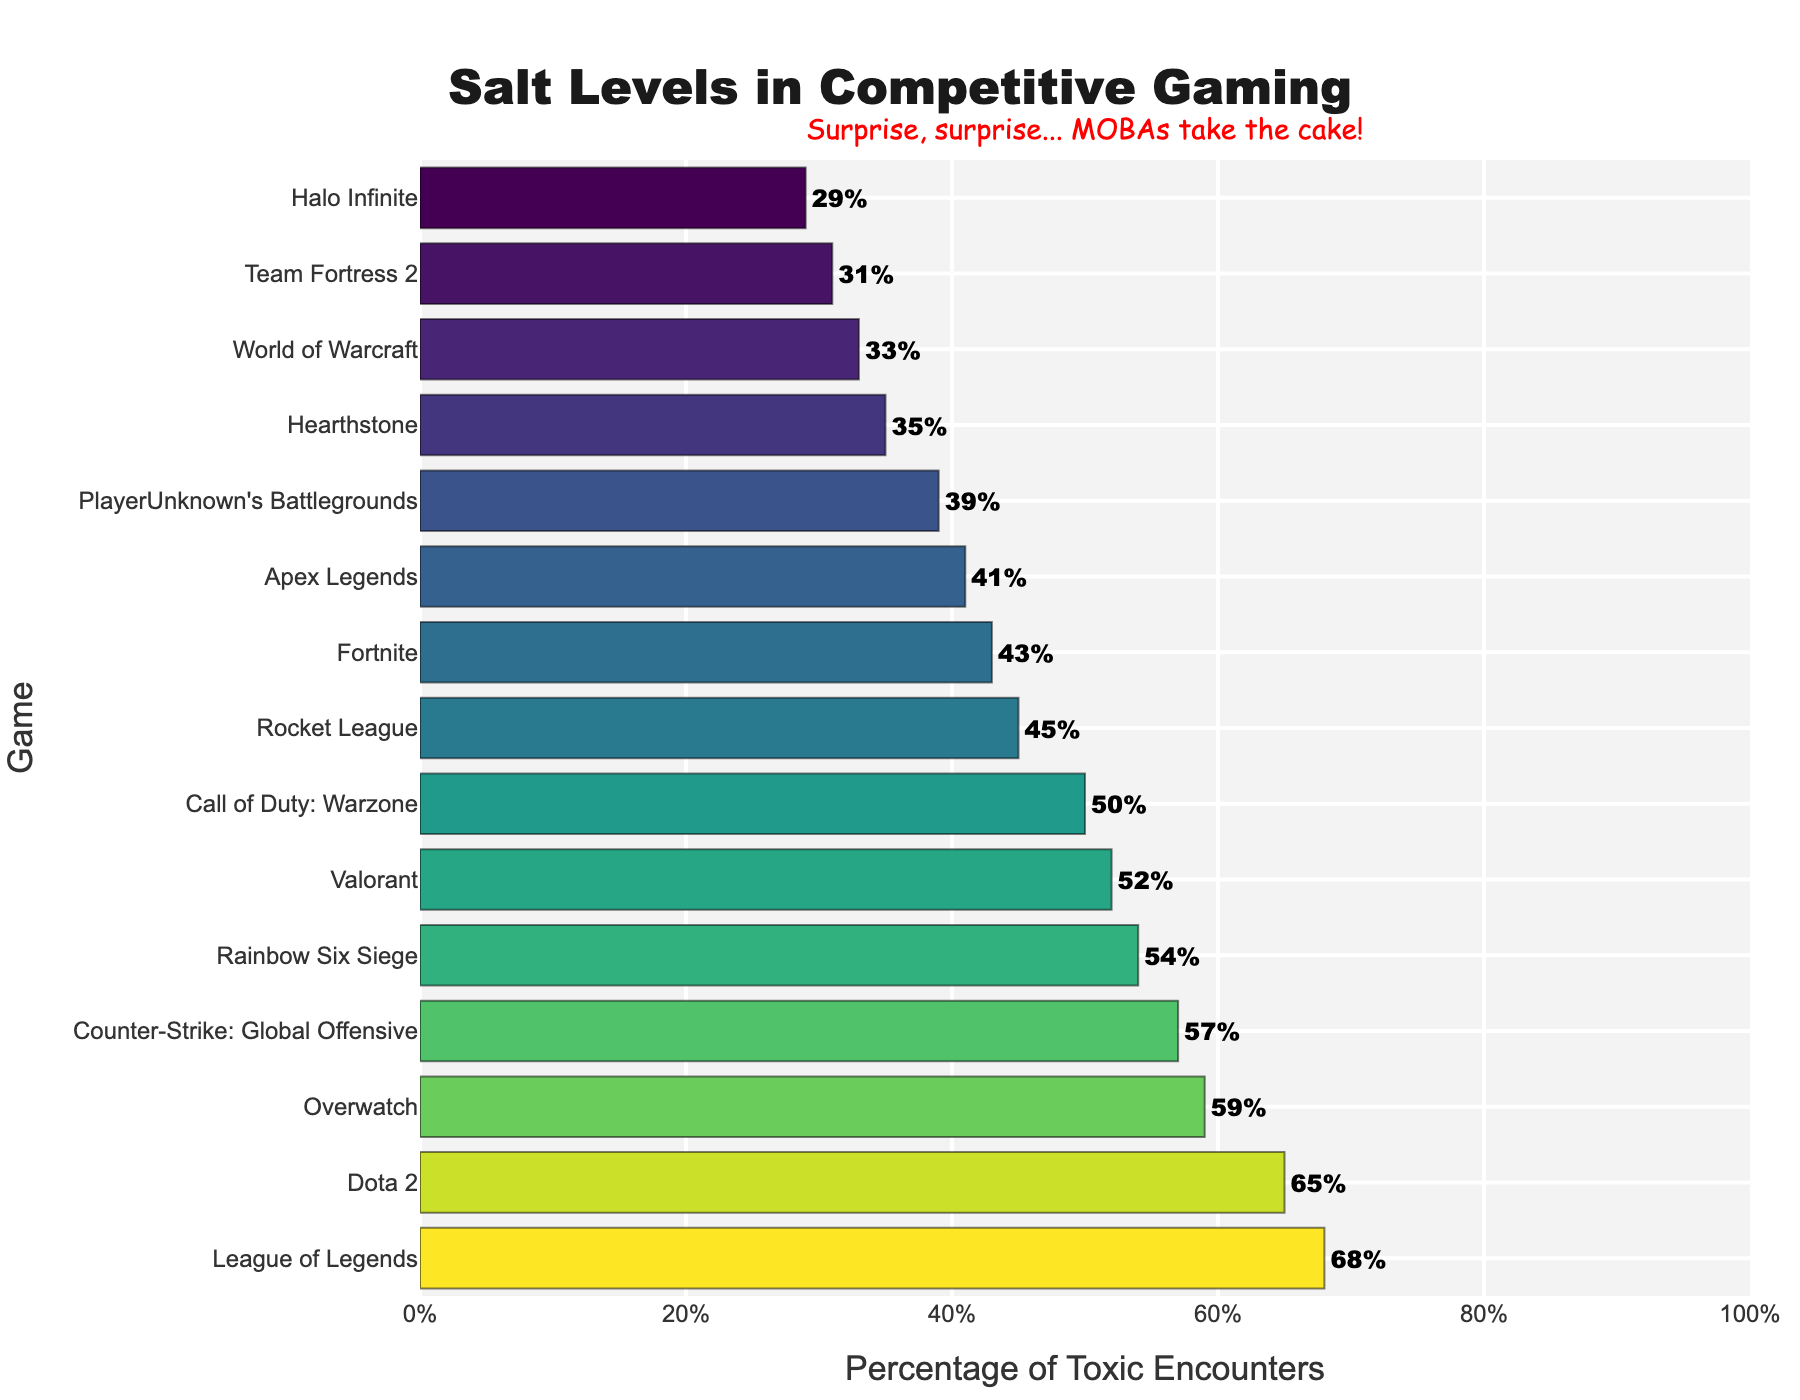what percentage of toxic encounters does League of Legends have? League of Legends has the bar with the highest value in the figure, which is labeled as 68%.
Answer: 68% which game has fewer toxic encounters, Fortnite or Valorant? Compare the lengths of the bars for Fortnite and Valorant. Fortnite is at 43%, and Valorant is at 52%, making Fortnite's value lower.
Answer: Fortnite what's the difference in the percentage of toxic encounters between Overwatch and Call of Duty: Warzone? Overwatch has 59% while Call of Duty: Warzone has 50%. The difference is 59 - 50 = 9%.
Answer: 9% which game is more toxic: Dota 2 or Counter-Strike: Global Offensive? Look at the bars for Dota 2 and Counter-Strike: Global Offensive. Dota 2 is at 65%, and CS:GO is at 57%, so Dota 2 is higher.
Answer: Dota 2 what's the median percentage of toxic encounters in the figure? To find the median, list all values in order and identify the middle one. Ordered percentages: 29, 31, 33, 35, 39, 41, 43, 45, 50, 52, 54, 57, 59, 65, 68. The middle value (8th) is 45%.
Answer: 45% which game has the least amount of toxic encounters? The shortest bar represents Halo Infinite, labeled with 29%.
Answer: Halo Infinite what's the total percentage of toxic encounters for League of Legends, Dota 2, and Counter-Strike: Global Offensive? Add the percentages for these games: League of Legends (68%), Dota 2 (65%), and Counter-Strike: Global Offensive (57%). 68 + 65 + 57 = 190%.
Answer: 190% how many games have a percentage of toxic encounters below 40%? Identify the bars below the 40% label: PlayerUnknown's Battlegrounds, Hearthstone, World of Warcraft, Team Fortress 2, and Halo Infinite. There are 5 games.
Answer: 5 